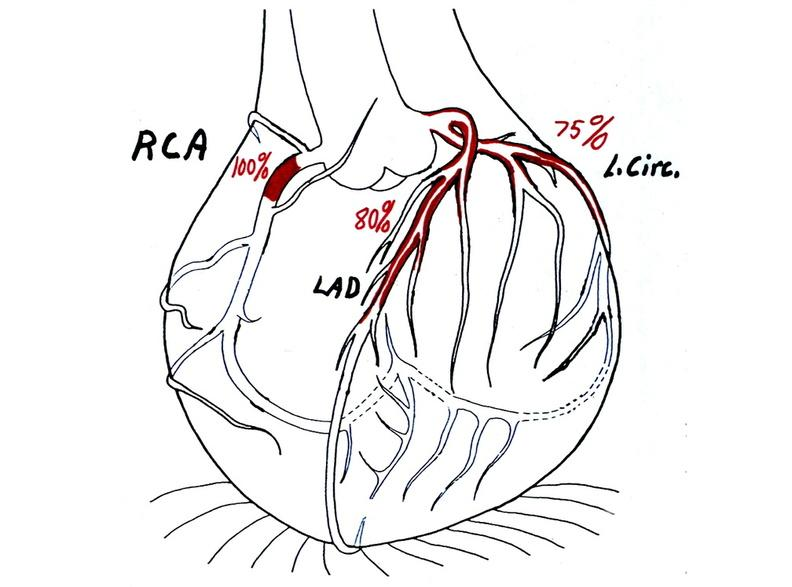what does this image show?
Answer the question using a single word or phrase. Coronary artery atherosclerosis diagram 